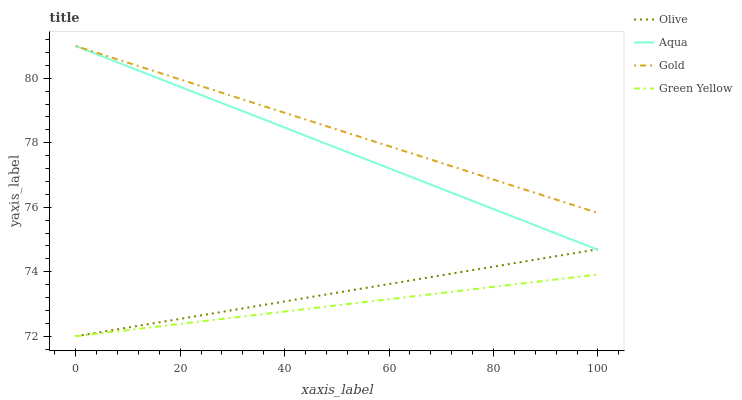Does Green Yellow have the minimum area under the curve?
Answer yes or no. Yes. Does Gold have the maximum area under the curve?
Answer yes or no. Yes. Does Aqua have the minimum area under the curve?
Answer yes or no. No. Does Aqua have the maximum area under the curve?
Answer yes or no. No. Is Green Yellow the smoothest?
Answer yes or no. Yes. Is Gold the roughest?
Answer yes or no. Yes. Is Aqua the smoothest?
Answer yes or no. No. Is Aqua the roughest?
Answer yes or no. No. Does Aqua have the lowest value?
Answer yes or no. No. Does Gold have the highest value?
Answer yes or no. Yes. Does Green Yellow have the highest value?
Answer yes or no. No. Is Olive less than Gold?
Answer yes or no. Yes. Is Gold greater than Green Yellow?
Answer yes or no. Yes. Does Olive intersect Green Yellow?
Answer yes or no. Yes. Is Olive less than Green Yellow?
Answer yes or no. No. Is Olive greater than Green Yellow?
Answer yes or no. No. Does Olive intersect Gold?
Answer yes or no. No. 